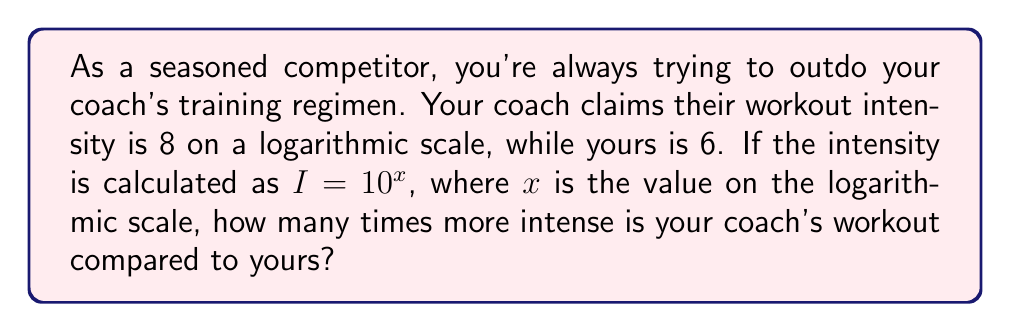Provide a solution to this math problem. Let's approach this step-by-step:

1) The intensity is calculated using the formula $I = 10^x$, where $x$ is the value on the logarithmic scale.

2) For your coach's workout:
   $I_c = 10^8$

3) For your workout:
   $I_y = 10^6$

4) To find how many times more intense your coach's workout is, we need to divide their intensity by yours:

   $$\frac{I_c}{I_y} = \frac{10^8}{10^6}$$

5) Using the laws of exponents, we can simplify this:

   $$\frac{10^8}{10^6} = 10^{8-6} = 10^2$$

6) Calculate the final value:

   $$10^2 = 100$$

Therefore, your coach's workout is 100 times more intense than yours according to this logarithmic scale.
Answer: 100 times 